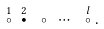Convert formula to latex. <formula><loc_0><loc_0><loc_500><loc_500>\stackrel { 1 } { \circ } \ \stackrel { 2 } { \bullet } \ \circ \ \cdots \ \stackrel { l } { \circ } .</formula> 